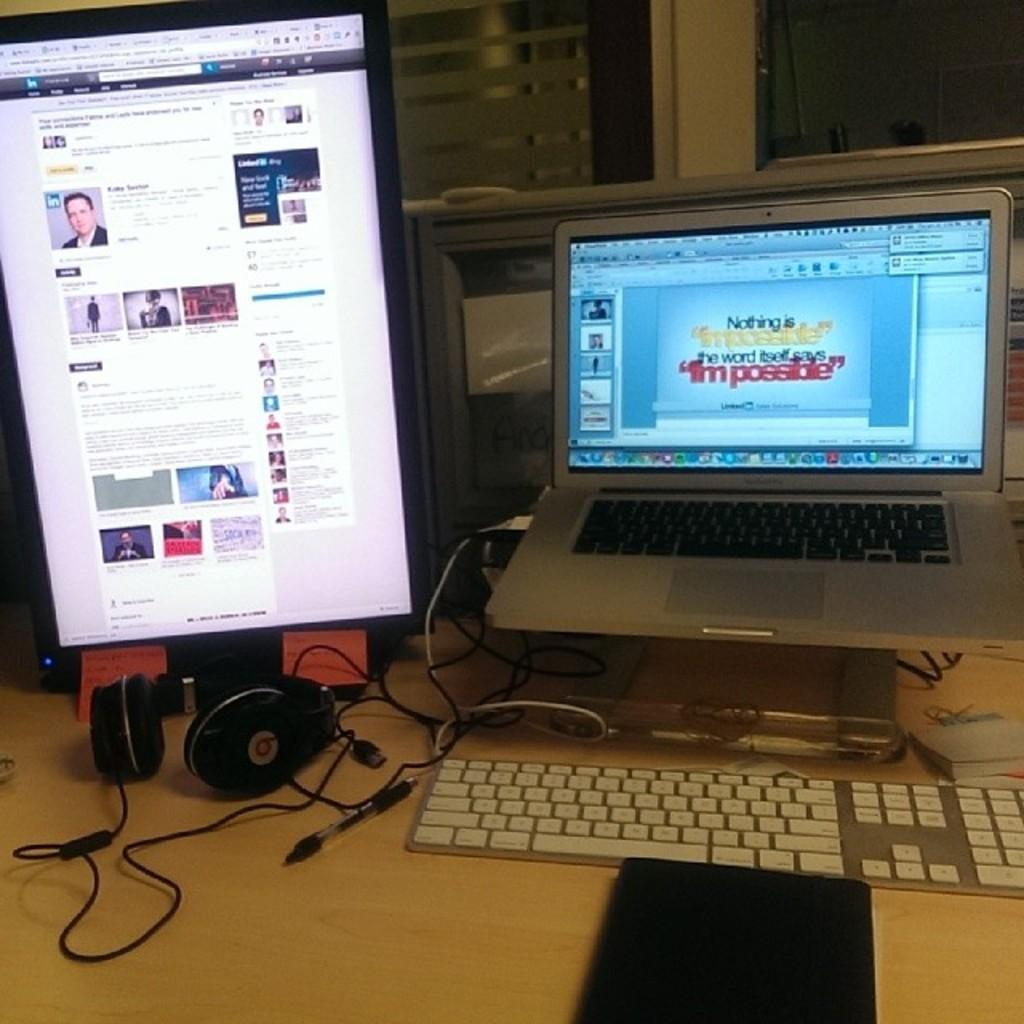Provide a one-sentence caption for the provided image. Someone is preparing a laptop presentation with motivational text about what is possible. 